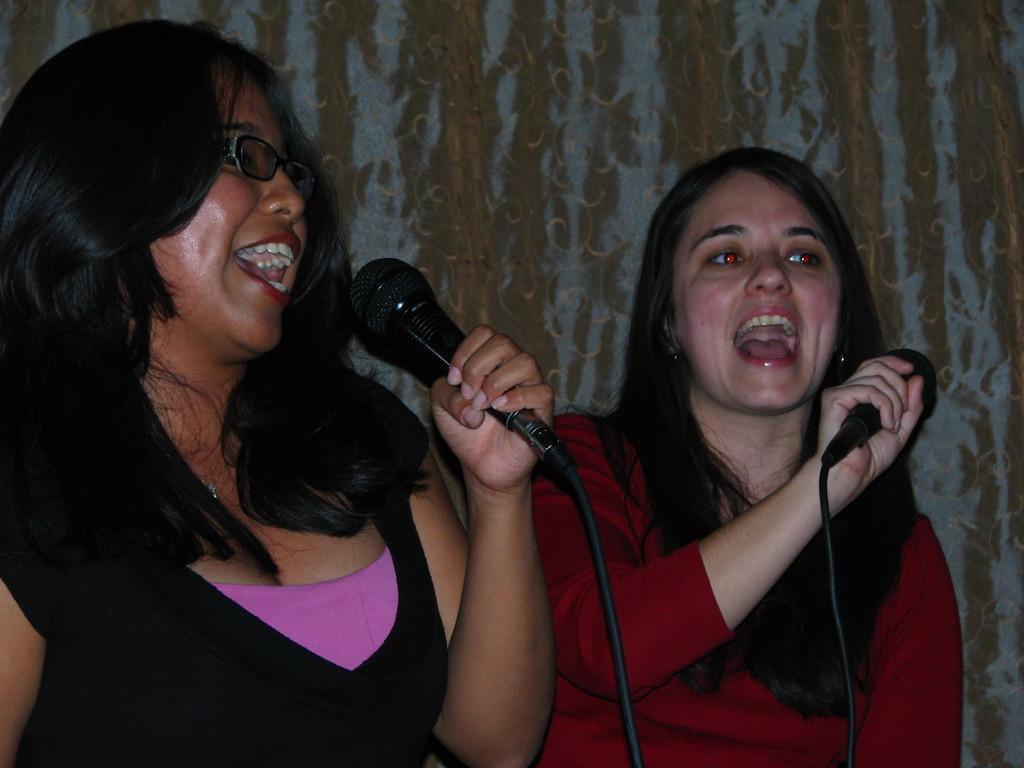Please provide a concise description of this image. The two women holding mike in their hands are singing. 